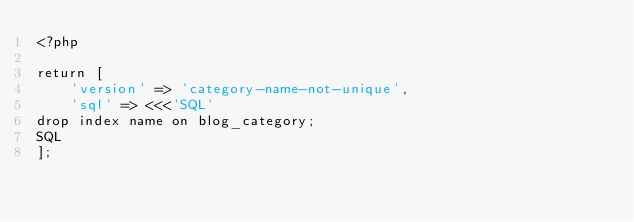Convert code to text. <code><loc_0><loc_0><loc_500><loc_500><_PHP_><?php

return [
    'version' => 'category-name-not-unique',
    'sql' => <<<'SQL'
drop index name on blog_category;
SQL
];</code> 